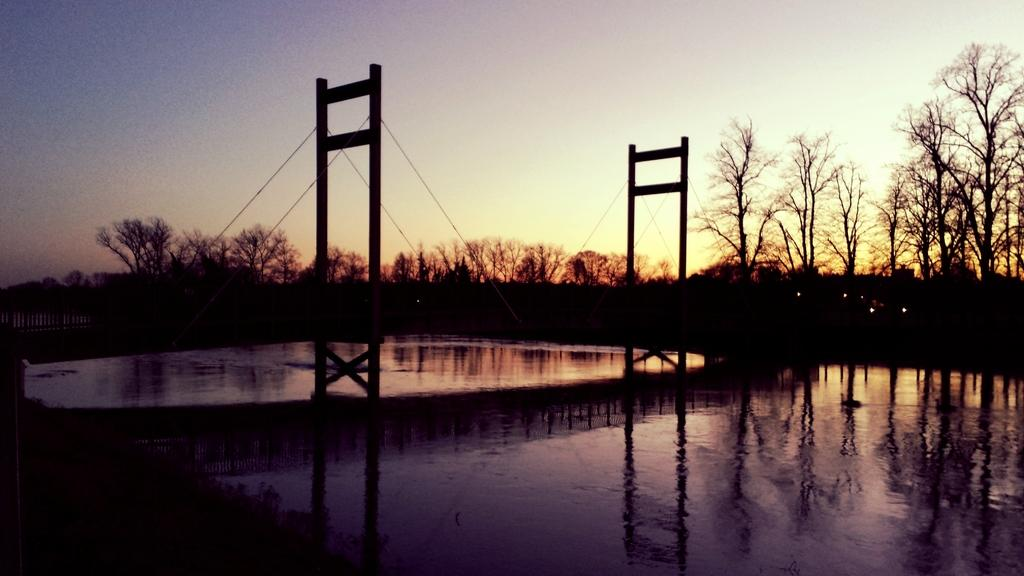What is the main structure visible in the image? There is a bridge in the middle of a water body. What can be seen in the background of the image? There are trees in the background of the image. How would you describe the sky in the image? The sky is clear in the image. Is there a volcano erupting in the background of the image? No, there is no volcano present in the image. What is the chance of adjusting the bridge's position in the image? The image is a static representation, so there is no chance of adjusting the bridge's position. 